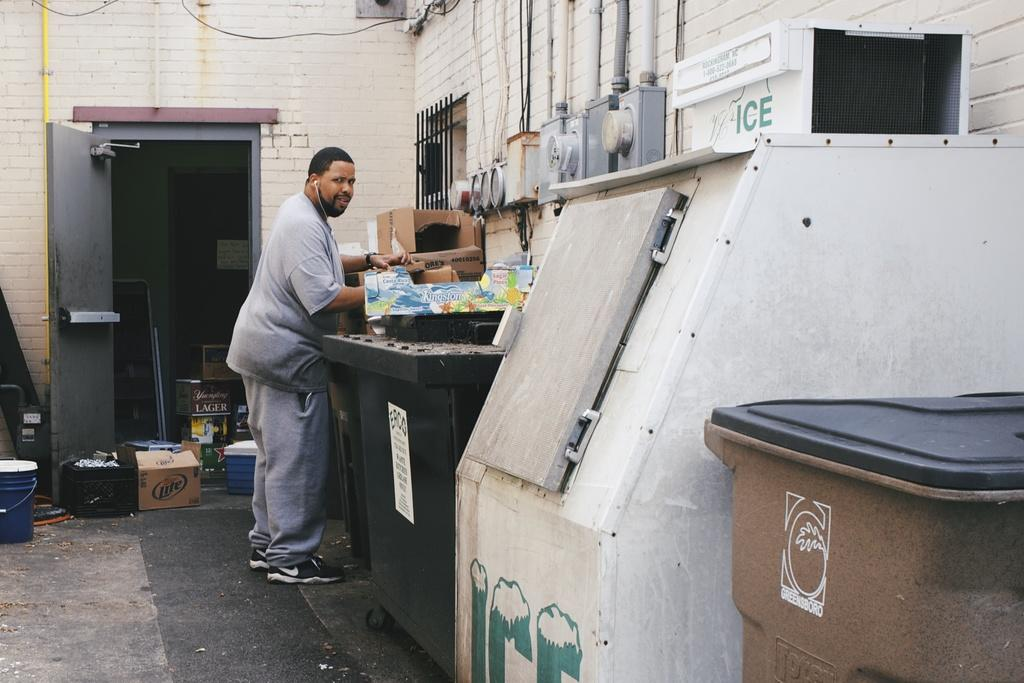<image>
Share a concise interpretation of the image provided. Man is standing outside looking near a ice machine 